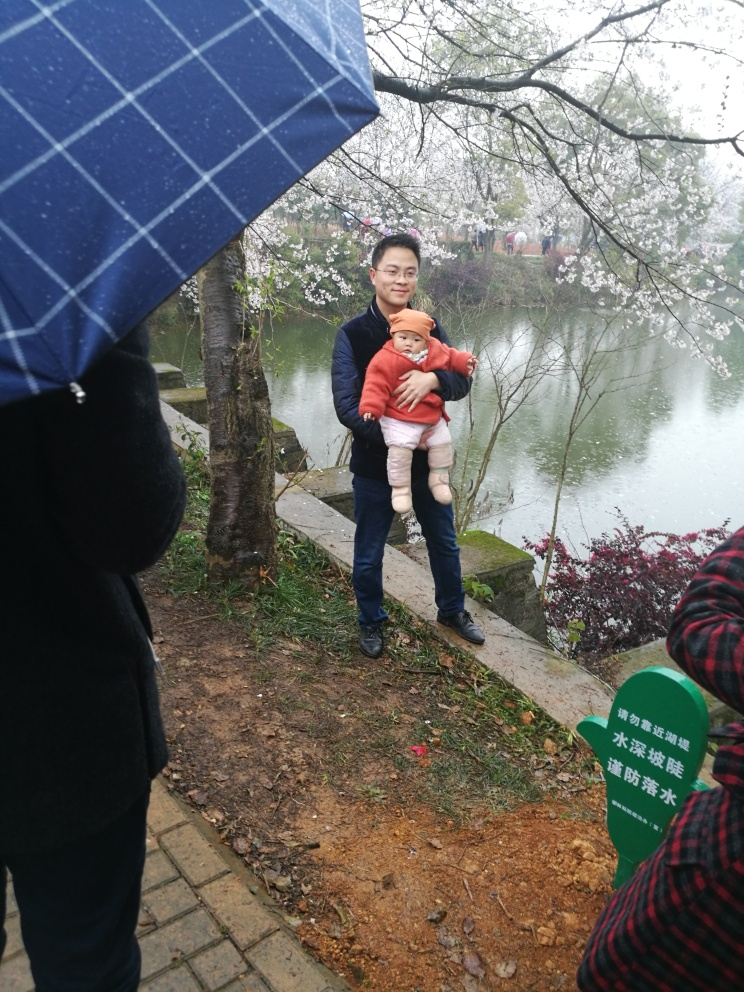What emotions does the person holding the child seem to be experiencing in this image? The person appears to be exhibiting a sense of contentment and care. Holding the child gently and showing a subtle smile, the person seems to be enjoying the moment despite the overcast weather. 